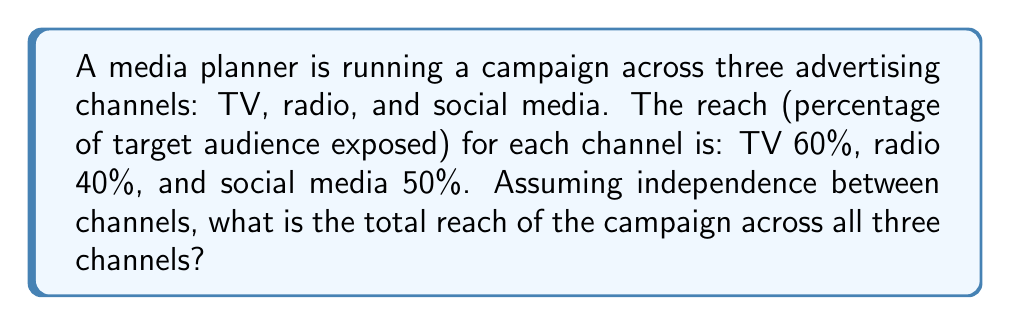What is the answer to this math problem? To solve this problem, we need to use the concept of probability and the complement rule. Here's a step-by-step explanation:

1. First, let's define the probabilities:
   $P(TV) = 0.60$
   $P(Radio) = 0.40$
   $P(Social) = 0.50$

2. We want to find the probability that a person is reached by at least one of the channels. It's easier to calculate the probability that a person is not reached by any channel and then subtract that from 1.

3. The probability of not being reached by TV: $1 - 0.60 = 0.40$
   The probability of not being reached by radio: $1 - 0.40 = 0.60$
   The probability of not being reached by social media: $1 - 0.50 = 0.50$

4. Assuming independence, the probability of not being reached by any channel is the product of these probabilities:

   $P(\text{not reached}) = 0.40 \times 0.60 \times 0.50 = 0.12$

5. Therefore, the probability of being reached by at least one channel (total reach) is:

   $P(\text{reached}) = 1 - P(\text{not reached}) = 1 - 0.12 = 0.88$

6. Convert to percentage: $0.88 \times 100\% = 88\%$
Answer: 88% 